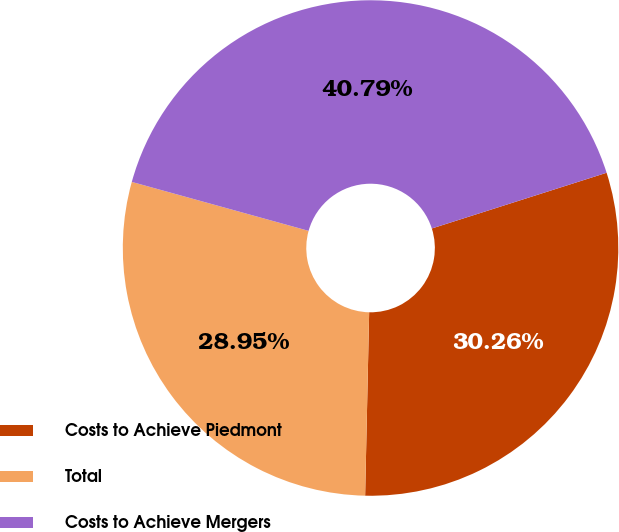<chart> <loc_0><loc_0><loc_500><loc_500><pie_chart><fcel>Costs to Achieve Piedmont<fcel>Total<fcel>Costs to Achieve Mergers<nl><fcel>30.26%<fcel>28.95%<fcel>40.79%<nl></chart> 